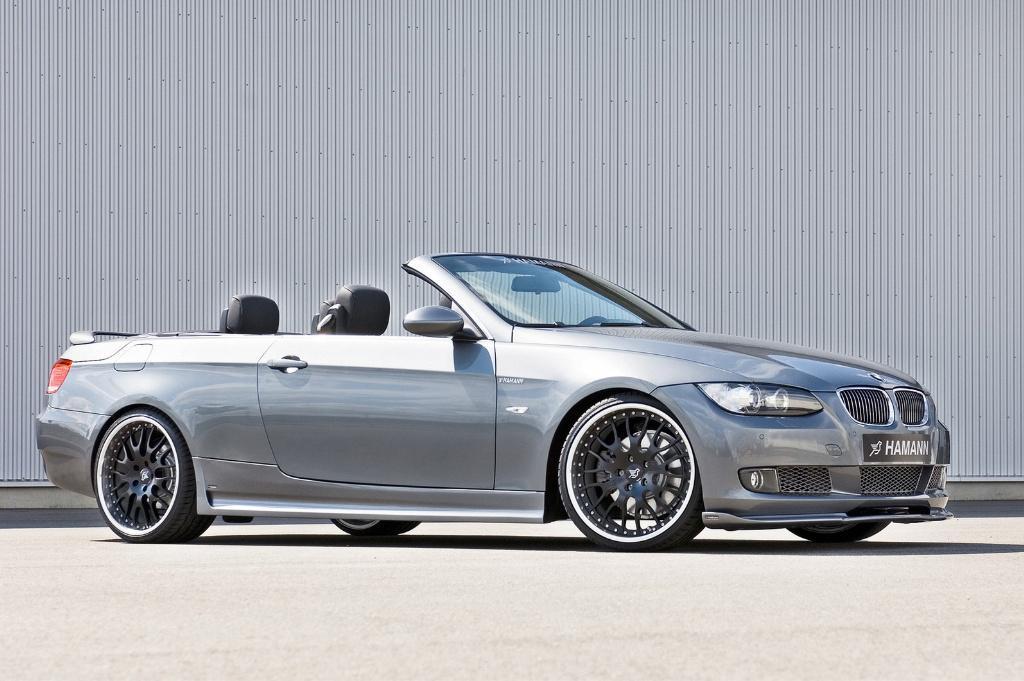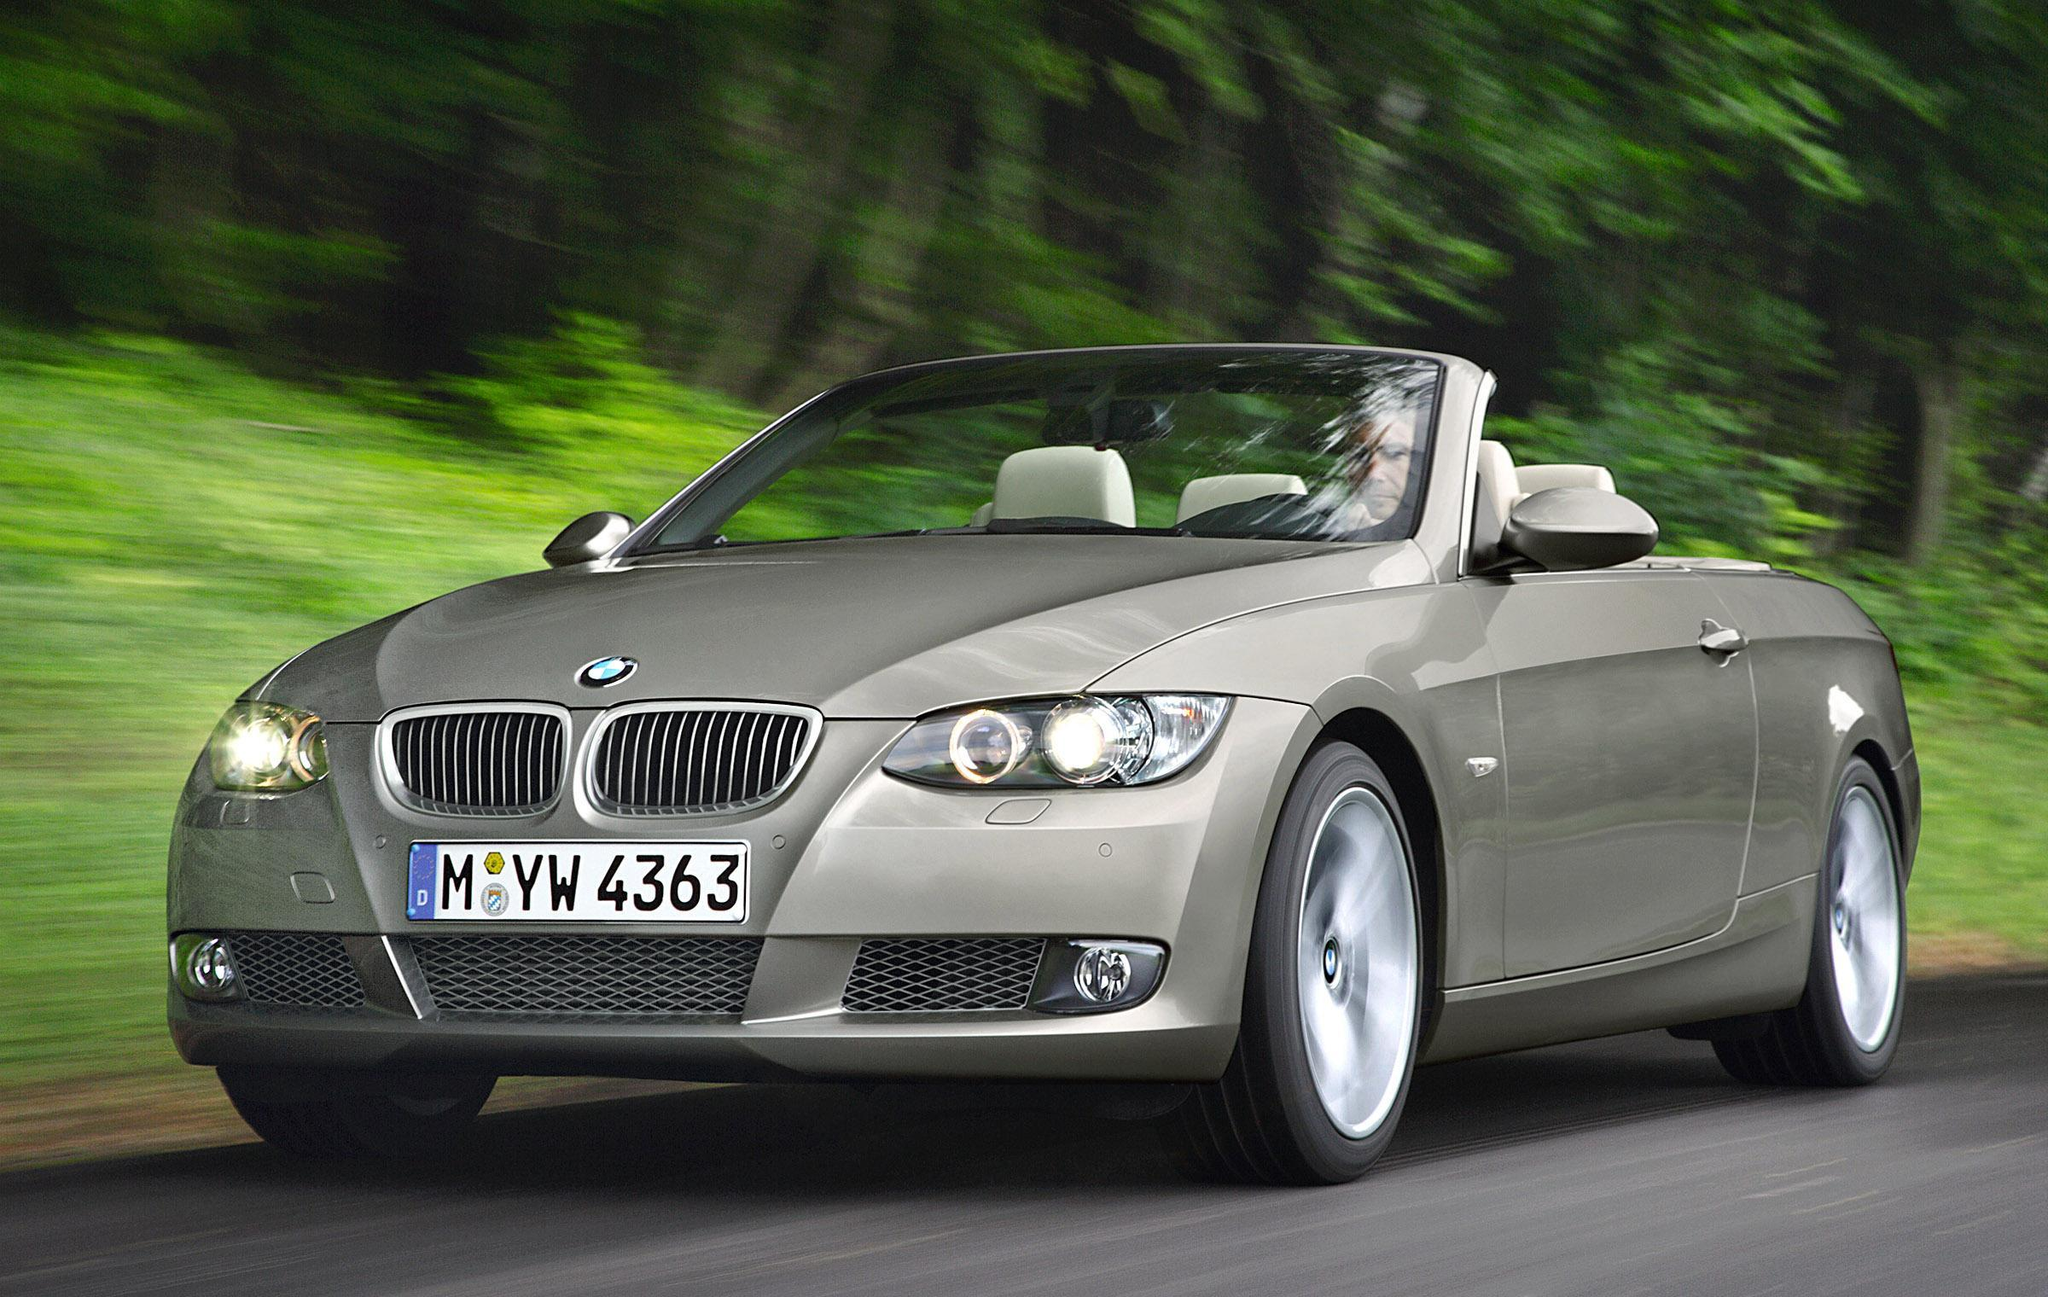The first image is the image on the left, the second image is the image on the right. Assess this claim about the two images: "Two convertible sports cars are parked so that their license plates are visible, one blue with white seat headrests and one silver metallic.". Correct or not? Answer yes or no. No. The first image is the image on the left, the second image is the image on the right. Assess this claim about the two images: "An image shows a parked deep blue convertible with noone inside it.". Correct or not? Answer yes or no. No. 